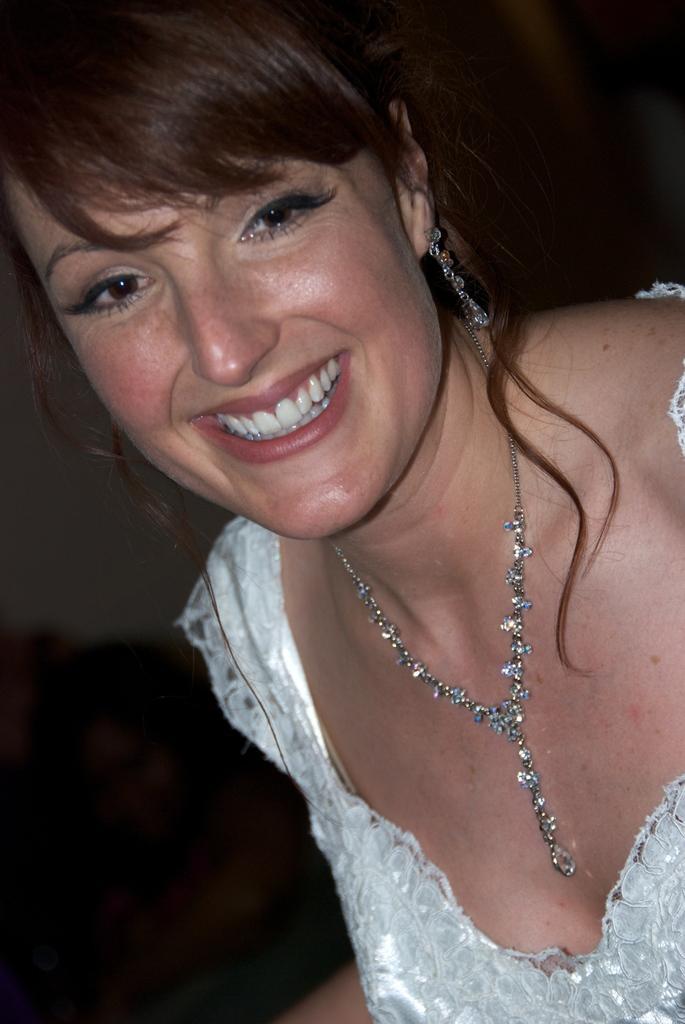Describe this image in one or two sentences. In this image there is a woman with a smile on her face. 